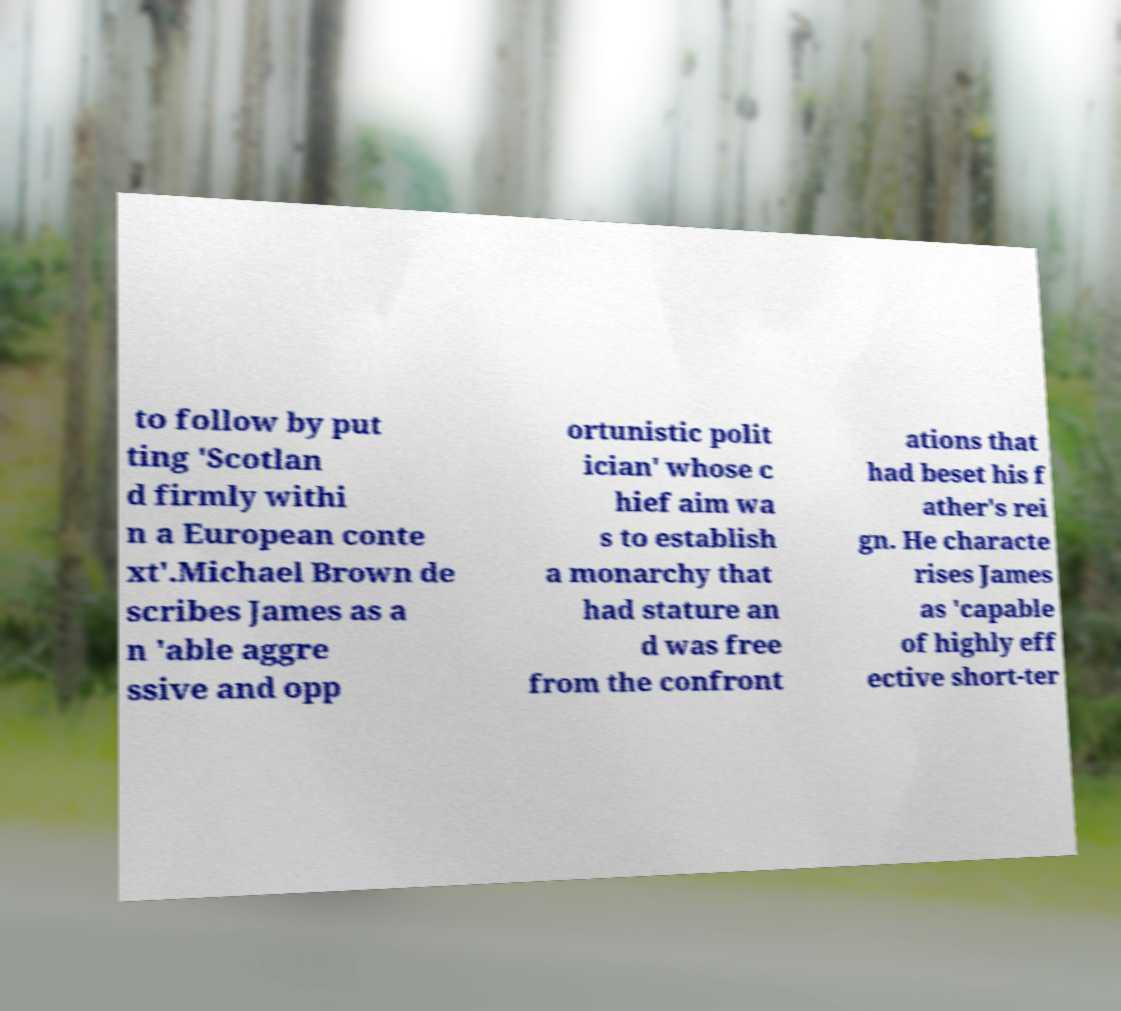Please read and relay the text visible in this image. What does it say? to follow by put ting 'Scotlan d firmly withi n a European conte xt'.Michael Brown de scribes James as a n 'able aggre ssive and opp ortunistic polit ician' whose c hief aim wa s to establish a monarchy that had stature an d was free from the confront ations that had beset his f ather's rei gn. He characte rises James as 'capable of highly eff ective short-ter 